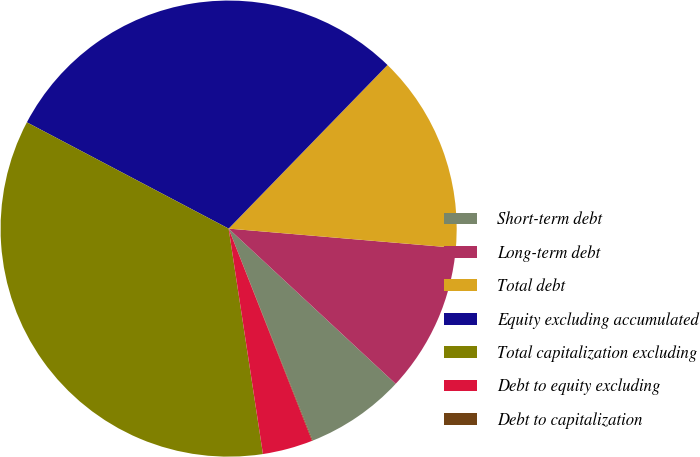<chart> <loc_0><loc_0><loc_500><loc_500><pie_chart><fcel>Short-term debt<fcel>Long-term debt<fcel>Total debt<fcel>Equity excluding accumulated<fcel>Total capitalization excluding<fcel>Debt to equity excluding<fcel>Debt to capitalization<nl><fcel>7.07%<fcel>10.57%<fcel>14.08%<fcel>29.55%<fcel>35.12%<fcel>3.56%<fcel>0.05%<nl></chart> 